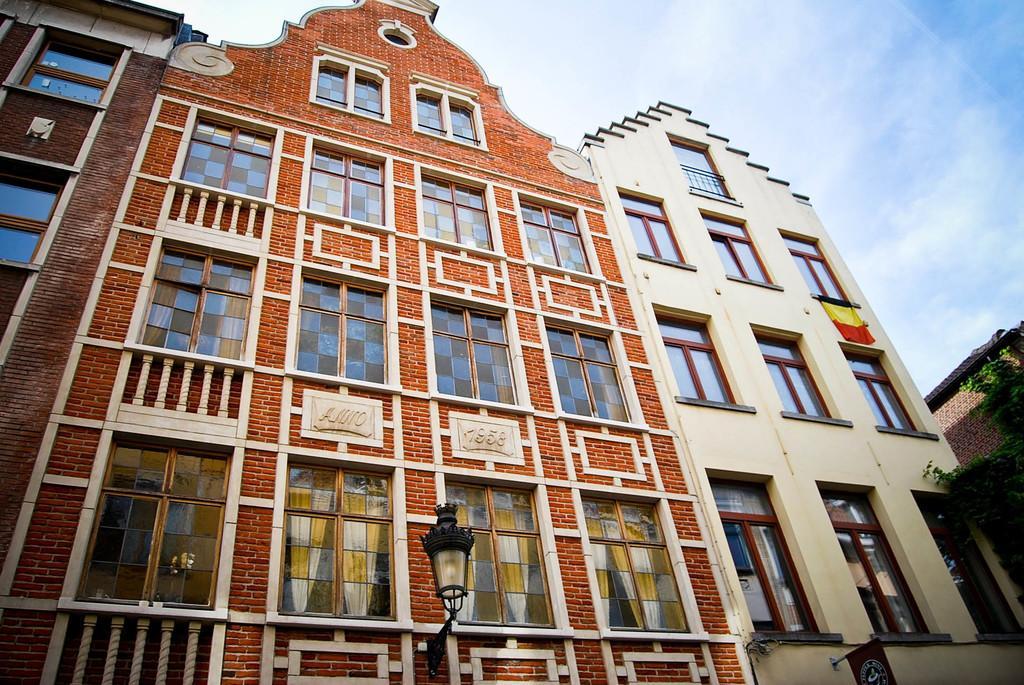Please provide a concise description of this image. In this image there is a building in the middle of this image. There is a lamp in the bottom of this image. There is a sky on the top of this image. 